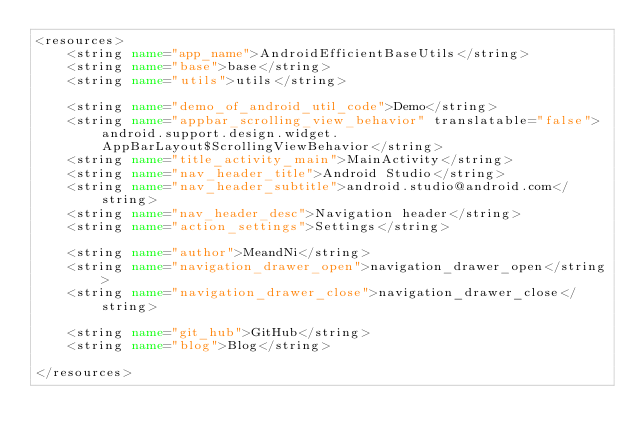Convert code to text. <code><loc_0><loc_0><loc_500><loc_500><_XML_><resources>
    <string name="app_name">AndroidEfficientBaseUtils</string>
    <string name="base">base</string>
    <string name="utils">utils</string>

    <string name="demo_of_android_util_code">Demo</string>
    <string name="appbar_scrolling_view_behavior" translatable="false">android.support.design.widget.AppBarLayout$ScrollingViewBehavior</string>
    <string name="title_activity_main">MainActivity</string>
    <string name="nav_header_title">Android Studio</string>
    <string name="nav_header_subtitle">android.studio@android.com</string>
    <string name="nav_header_desc">Navigation header</string>
    <string name="action_settings">Settings</string>

    <string name="author">MeandNi</string>
    <string name="navigation_drawer_open">navigation_drawer_open</string>
    <string name="navigation_drawer_close">navigation_drawer_close</string>

    <string name="git_hub">GitHub</string>
    <string name="blog">Blog</string>

</resources>
</code> 